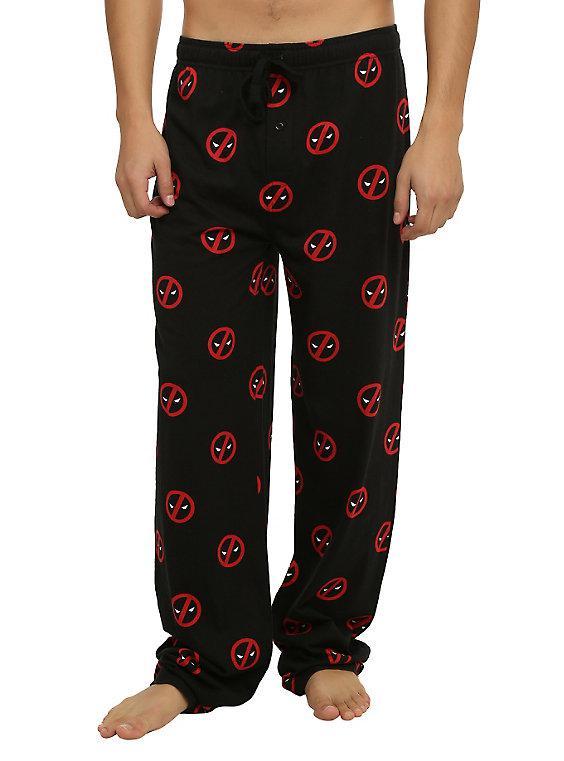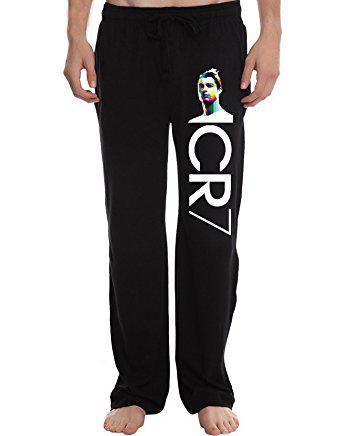The first image is the image on the left, the second image is the image on the right. Assess this claim about the two images: "The pants do not have a repeating pattern on them.". Correct or not? Answer yes or no. No. 